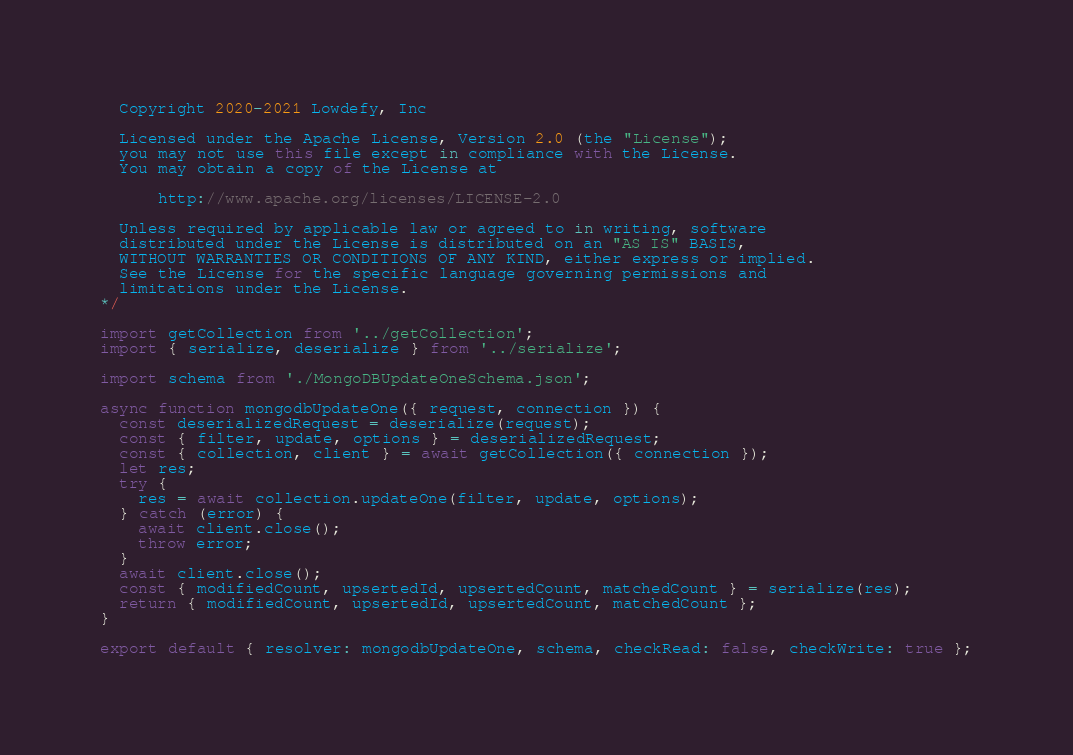<code> <loc_0><loc_0><loc_500><loc_500><_JavaScript_>  Copyright 2020-2021 Lowdefy, Inc

  Licensed under the Apache License, Version 2.0 (the "License");
  you may not use this file except in compliance with the License.
  You may obtain a copy of the License at

      http://www.apache.org/licenses/LICENSE-2.0

  Unless required by applicable law or agreed to in writing, software
  distributed under the License is distributed on an "AS IS" BASIS,
  WITHOUT WARRANTIES OR CONDITIONS OF ANY KIND, either express or implied.
  See the License for the specific language governing permissions and
  limitations under the License.
*/

import getCollection from '../getCollection';
import { serialize, deserialize } from '../serialize';

import schema from './MongoDBUpdateOneSchema.json';

async function mongodbUpdateOne({ request, connection }) {
  const deserializedRequest = deserialize(request);
  const { filter, update, options } = deserializedRequest;
  const { collection, client } = await getCollection({ connection });
  let res;
  try {
    res = await collection.updateOne(filter, update, options);
  } catch (error) {
    await client.close();
    throw error;
  }
  await client.close();
  const { modifiedCount, upsertedId, upsertedCount, matchedCount } = serialize(res);
  return { modifiedCount, upsertedId, upsertedCount, matchedCount };
}

export default { resolver: mongodbUpdateOne, schema, checkRead: false, checkWrite: true };
</code> 